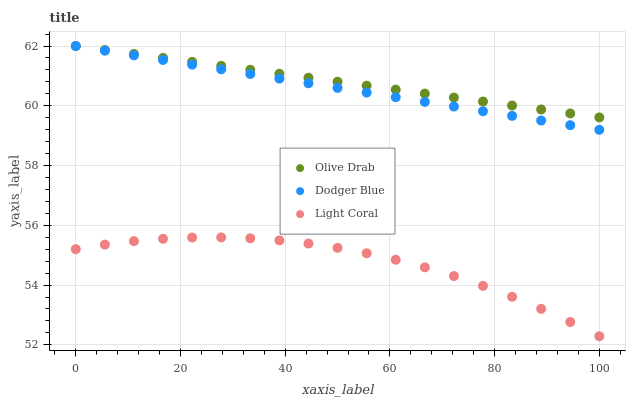Does Light Coral have the minimum area under the curve?
Answer yes or no. Yes. Does Olive Drab have the maximum area under the curve?
Answer yes or no. Yes. Does Dodger Blue have the minimum area under the curve?
Answer yes or no. No. Does Dodger Blue have the maximum area under the curve?
Answer yes or no. No. Is Olive Drab the smoothest?
Answer yes or no. Yes. Is Light Coral the roughest?
Answer yes or no. Yes. Is Dodger Blue the smoothest?
Answer yes or no. No. Is Dodger Blue the roughest?
Answer yes or no. No. Does Light Coral have the lowest value?
Answer yes or no. Yes. Does Dodger Blue have the lowest value?
Answer yes or no. No. Does Olive Drab have the highest value?
Answer yes or no. Yes. Is Light Coral less than Dodger Blue?
Answer yes or no. Yes. Is Dodger Blue greater than Light Coral?
Answer yes or no. Yes. Does Olive Drab intersect Dodger Blue?
Answer yes or no. Yes. Is Olive Drab less than Dodger Blue?
Answer yes or no. No. Is Olive Drab greater than Dodger Blue?
Answer yes or no. No. Does Light Coral intersect Dodger Blue?
Answer yes or no. No. 